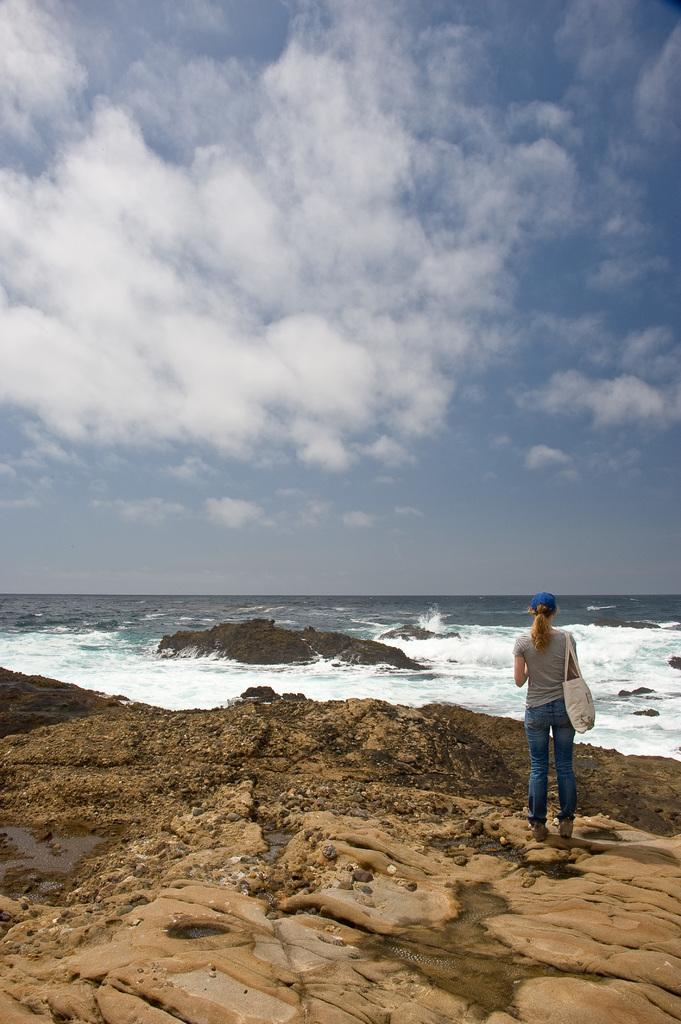What is the main subject of the image? There is a woman standing in the image. What is the woman wearing in the image? The woman is wearing a handbag. What type of natural element can be seen in the image? There is water visible in the image. What is visible in the background of the image? The sky is visible in the image, and clouds are present in the sky. What type of minister is standing near the water in the image? There is no minister present in the image; it features a woman standing. How many robins can be seen flying over the water in the image? There are no robins visible in the image; it only shows a woman standing near water. 